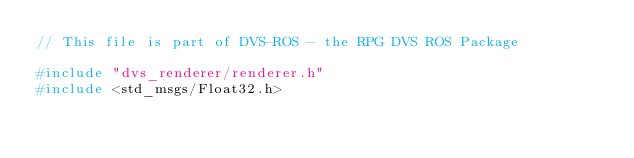Convert code to text. <code><loc_0><loc_0><loc_500><loc_500><_C++_>// This file is part of DVS-ROS - the RPG DVS ROS Package

#include "dvs_renderer/renderer.h"
#include <std_msgs/Float32.h>
</code> 